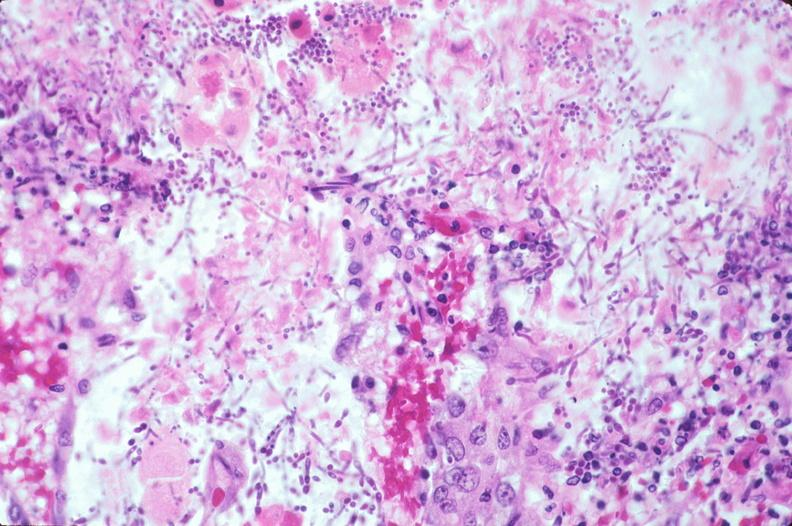s stillborn cord around neck present?
Answer the question using a single word or phrase. No 